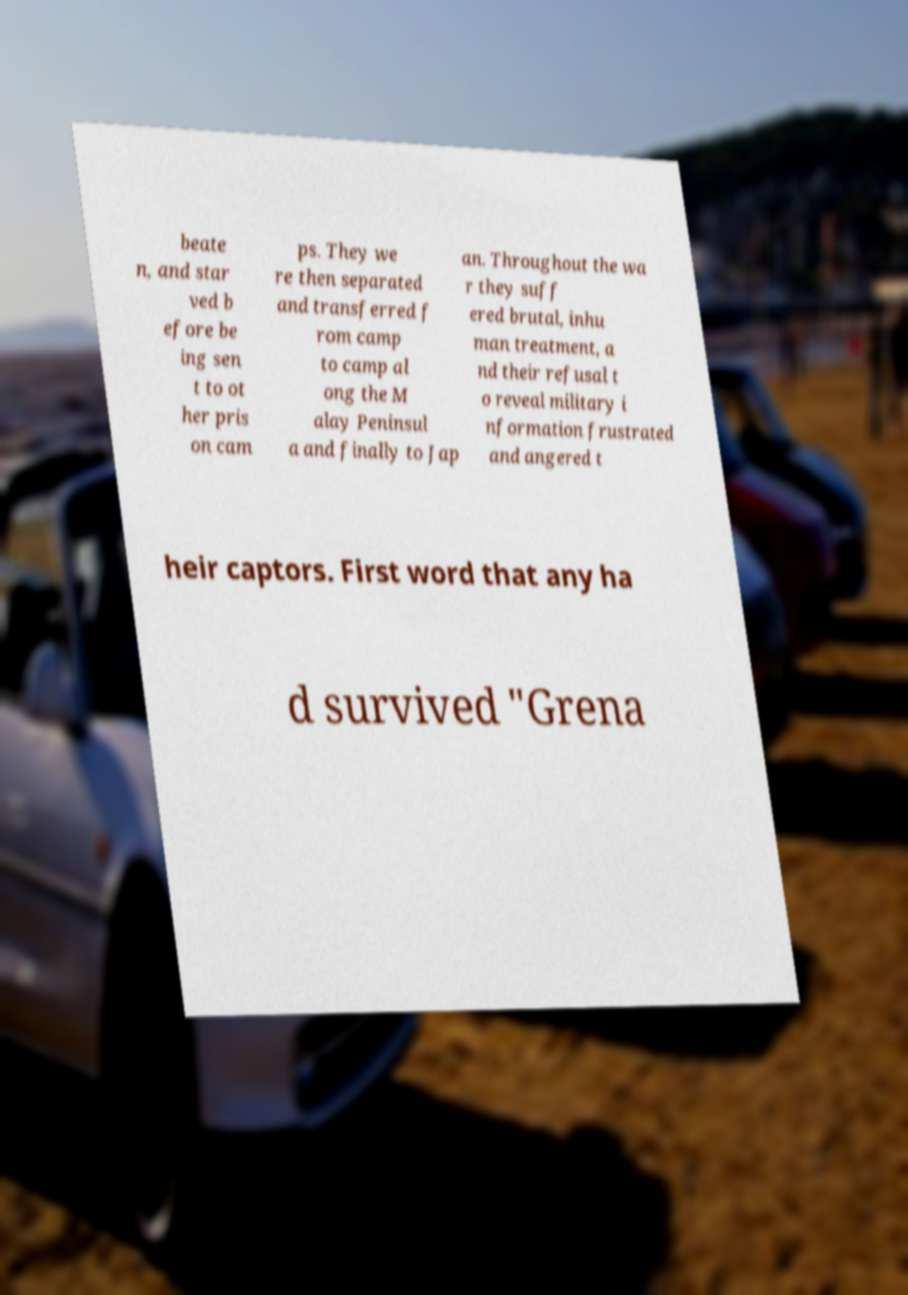For documentation purposes, I need the text within this image transcribed. Could you provide that? beate n, and star ved b efore be ing sen t to ot her pris on cam ps. They we re then separated and transferred f rom camp to camp al ong the M alay Peninsul a and finally to Jap an. Throughout the wa r they suff ered brutal, inhu man treatment, a nd their refusal t o reveal military i nformation frustrated and angered t heir captors. First word that any ha d survived "Grena 